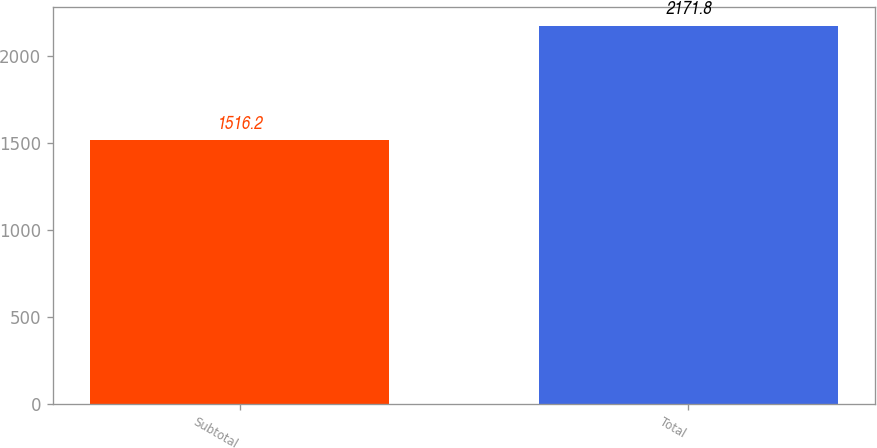Convert chart. <chart><loc_0><loc_0><loc_500><loc_500><bar_chart><fcel>Subtotal<fcel>Total<nl><fcel>1516.2<fcel>2171.8<nl></chart> 